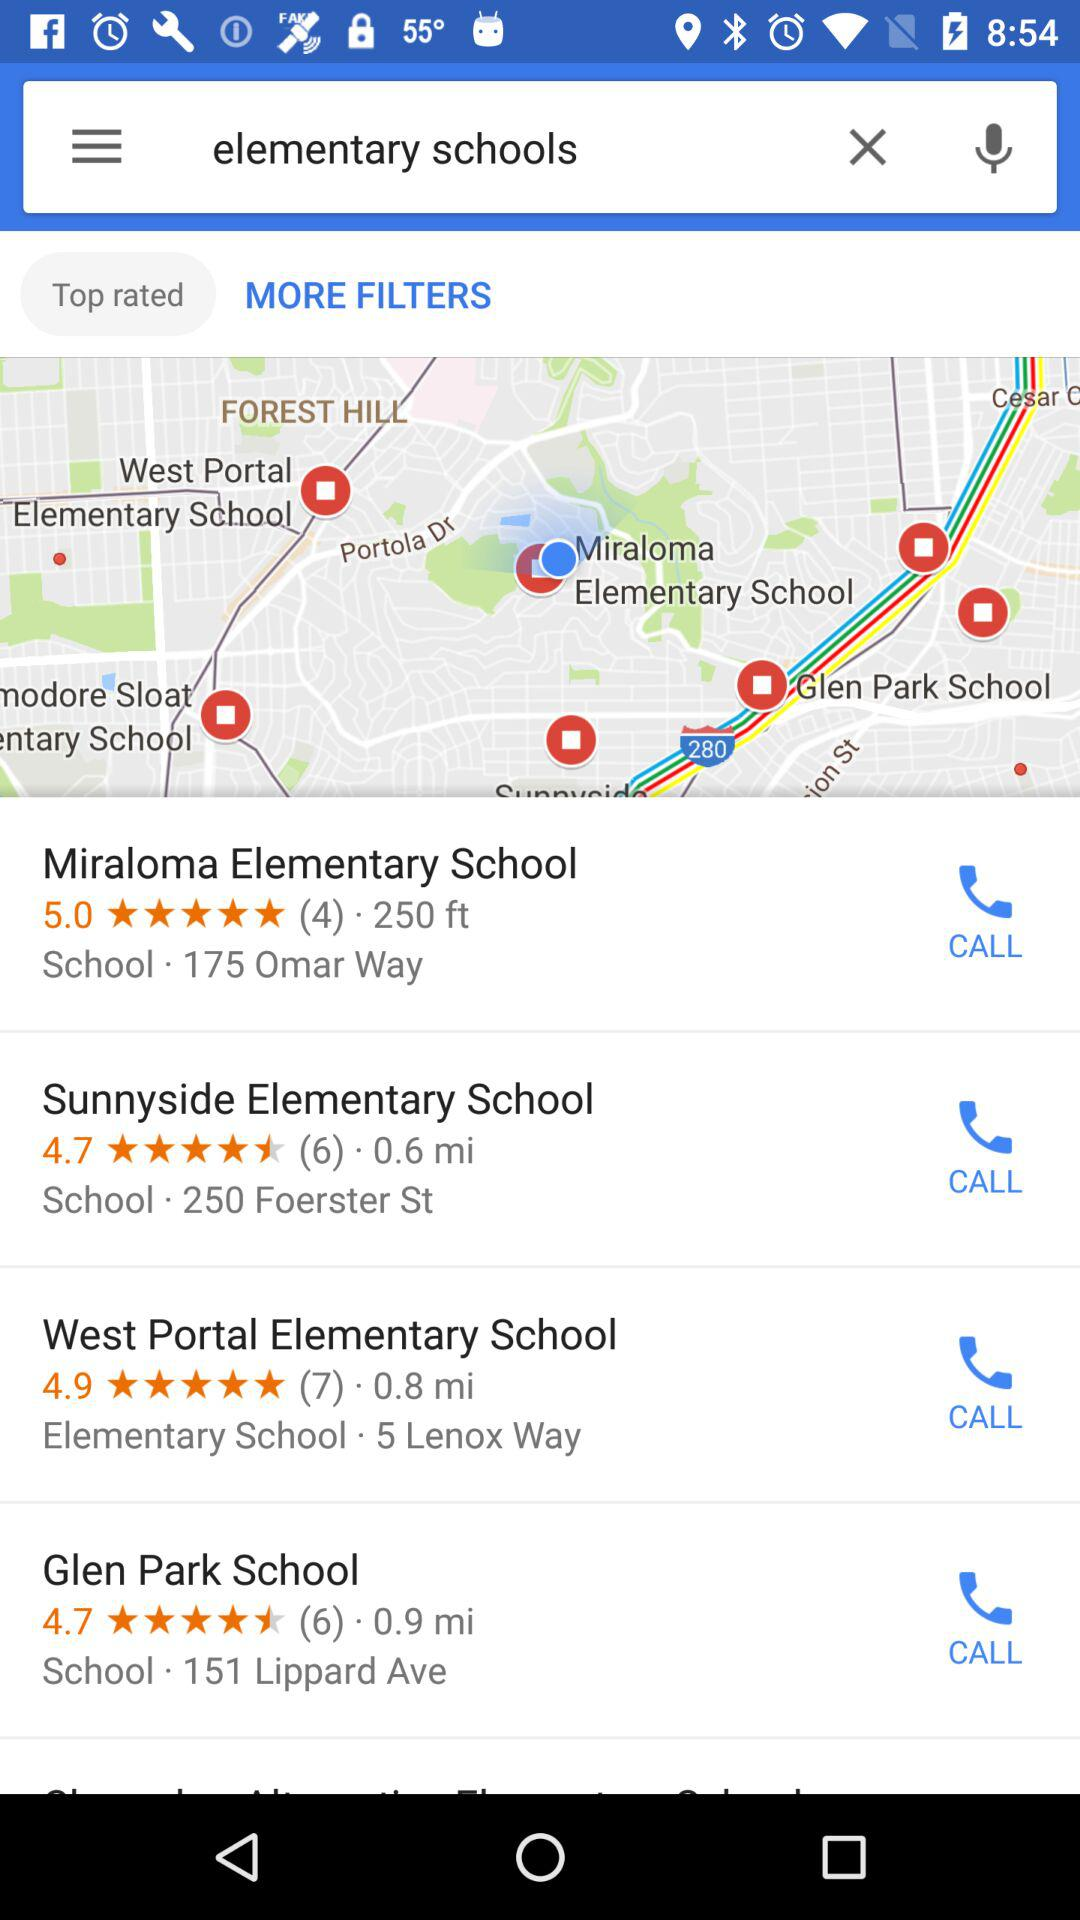How many elementary schools are there in the search results?
Answer the question using a single word or phrase. 4 